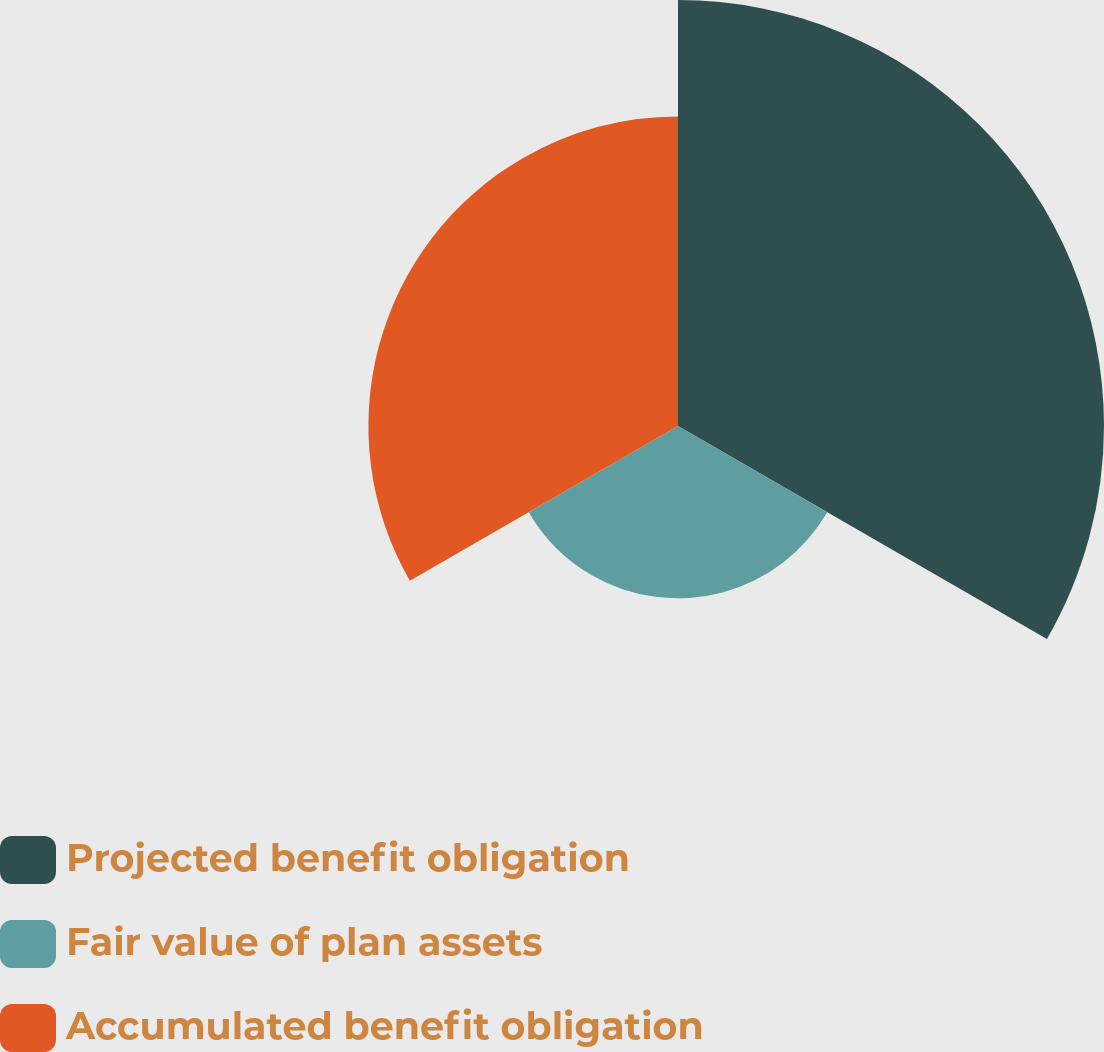Convert chart to OTSL. <chart><loc_0><loc_0><loc_500><loc_500><pie_chart><fcel>Projected benefit obligation<fcel>Fair value of plan assets<fcel>Accumulated benefit obligation<nl><fcel>46.92%<fcel>18.98%<fcel>34.1%<nl></chart> 